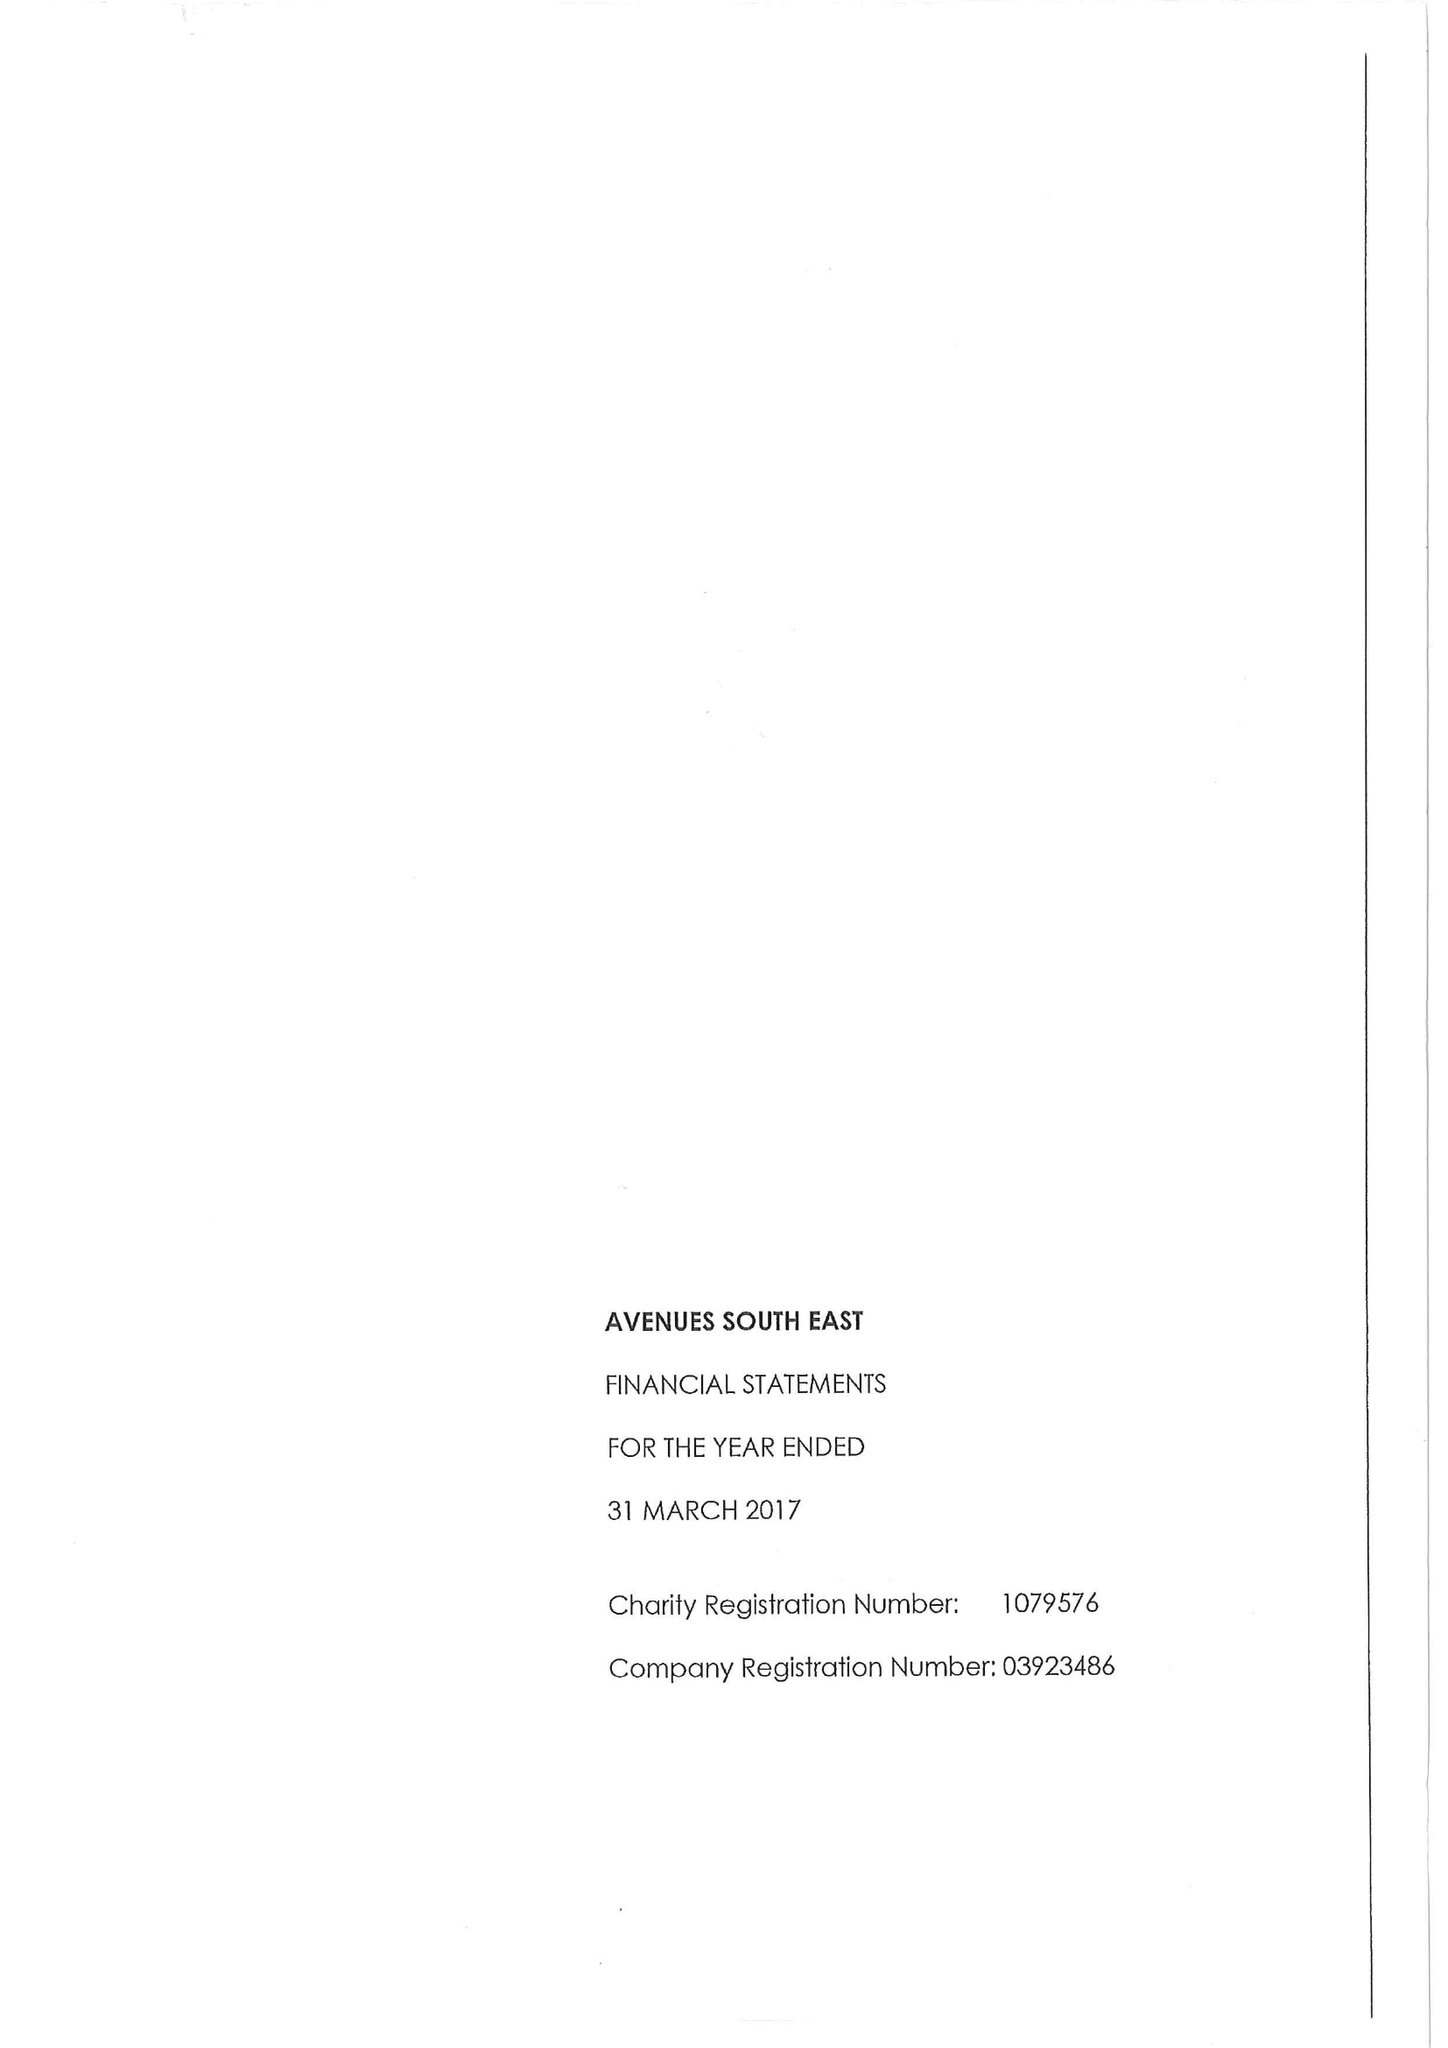What is the value for the address__postcode?
Answer the question using a single word or phrase. DA14 5TA 